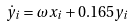<formula> <loc_0><loc_0><loc_500><loc_500>\dot { y } _ { i } = \omega x _ { i } + 0 . 1 6 5 y _ { i } \,</formula> 